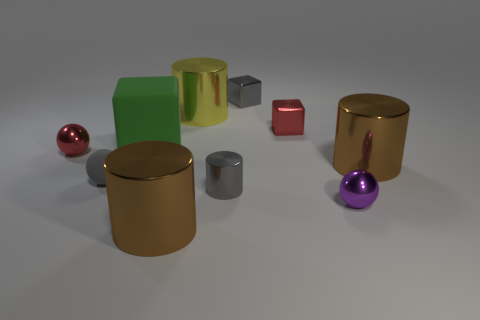What is the shape of the small red metallic object in front of the tiny red object that is on the right side of the green cube?
Ensure brevity in your answer.  Sphere. The purple metal object is what shape?
Your answer should be very brief. Sphere. There is a brown cylinder that is behind the big brown object left of the red metallic cube that is behind the green block; what is its material?
Provide a succinct answer. Metal. What number of other objects are there of the same material as the tiny cylinder?
Provide a succinct answer. 7. There is a tiny red metal thing right of the small gray rubber object; how many spheres are behind it?
Offer a very short reply. 0. How many blocks are either things or big green matte things?
Make the answer very short. 3. What color is the small object that is behind the tiny rubber thing and to the left of the large rubber cube?
Your answer should be very brief. Red. Is there any other thing that has the same color as the small metal cylinder?
Your response must be concise. Yes. There is a tiny shiny ball that is on the right side of the small shiny ball that is behind the small purple metal thing; what is its color?
Provide a short and direct response. Purple. Does the green thing have the same size as the gray metallic block?
Give a very brief answer. No. 